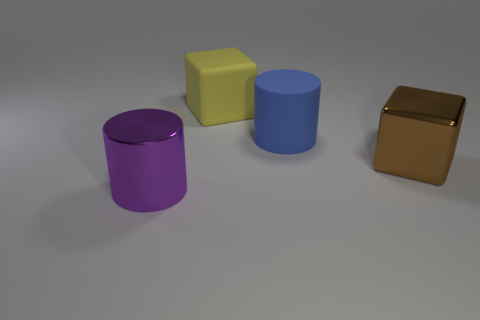What can the different shapes in the image tell us about the purpose of the scene? The different geometric shapes and the clean background suggest that this scene might be designed for a graphical presentation or a basic study of shape dimensionality and shading in a 3D modeling environment. How does the arrangement of shapes affect the composition of the image? The arrangement of the shapes in a staggered line provides a sense of depth and order, making it visually pleasing. It appears methodical, perhaps intending to draw the viewer's eye across the image and compare the forms and sizes of the objects. 